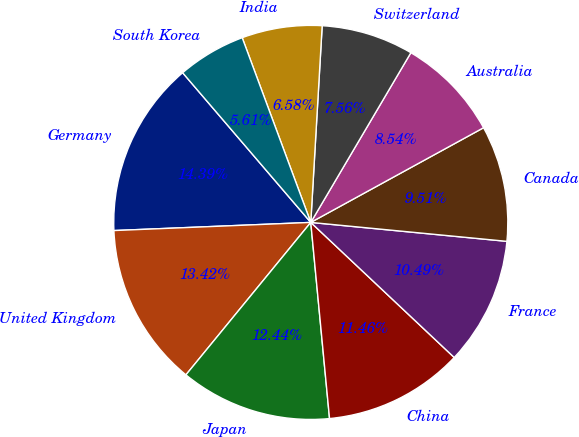<chart> <loc_0><loc_0><loc_500><loc_500><pie_chart><fcel>Germany<fcel>United Kingdom<fcel>Japan<fcel>China<fcel>France<fcel>Canada<fcel>Australia<fcel>Switzerland<fcel>India<fcel>South Korea<nl><fcel>14.39%<fcel>13.42%<fcel>12.44%<fcel>11.46%<fcel>10.49%<fcel>9.51%<fcel>8.54%<fcel>7.56%<fcel>6.58%<fcel>5.61%<nl></chart> 